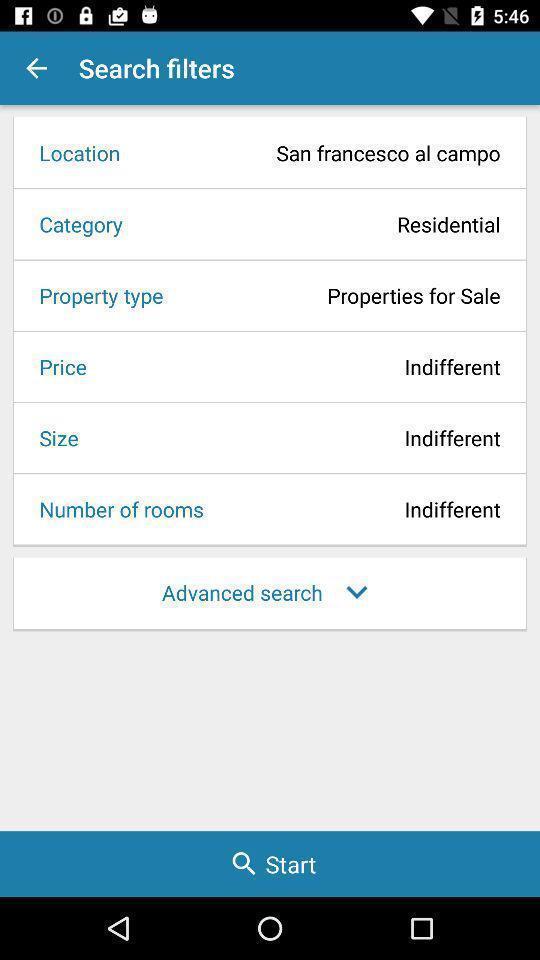Explain the elements present in this screenshot. Screen showing multiple options. 